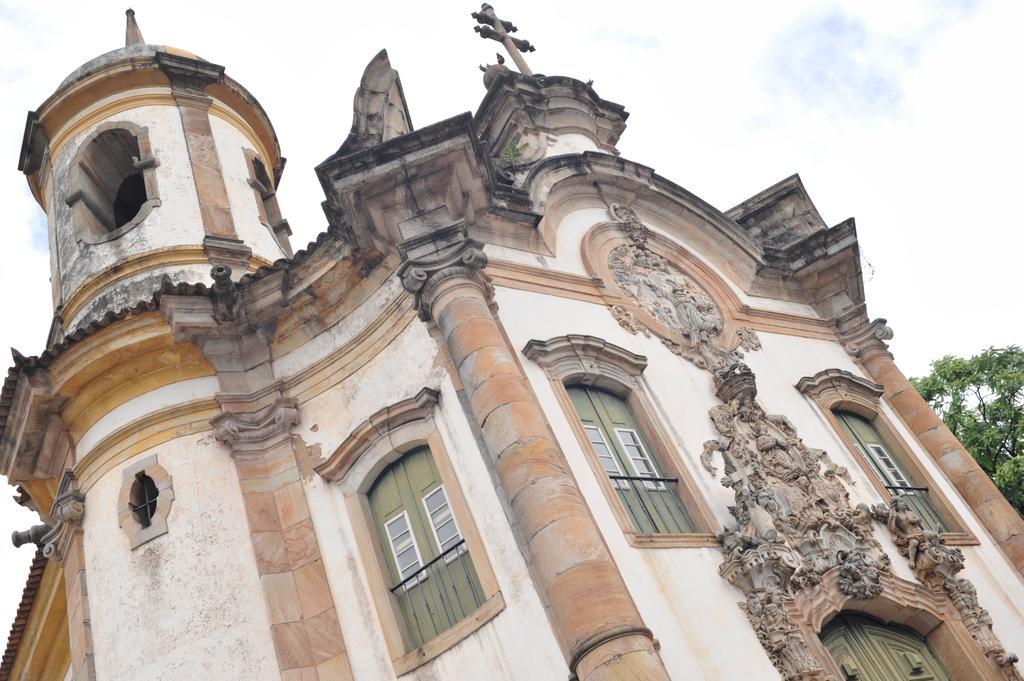How would you summarize this image in a sentence or two? In this picture I can see a building and a tree and I can see few stone carvings on the wall and a cloudy sky. 